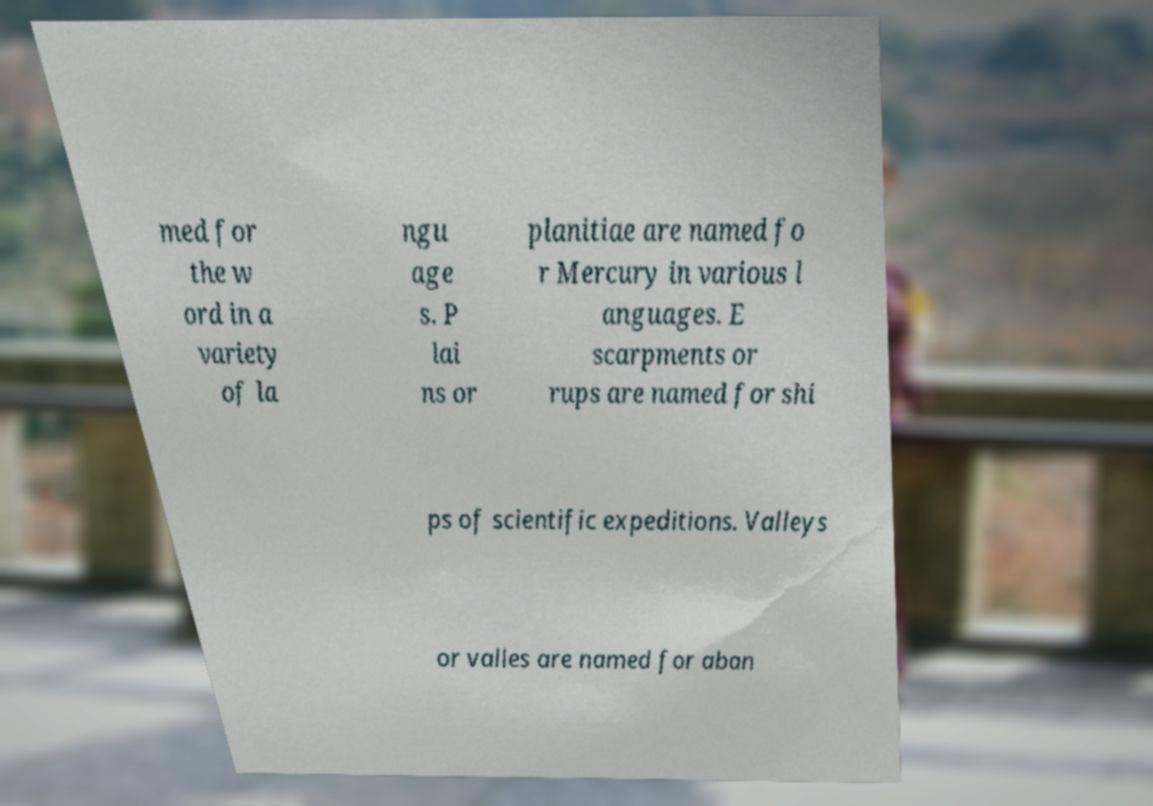There's text embedded in this image that I need extracted. Can you transcribe it verbatim? med for the w ord in a variety of la ngu age s. P lai ns or planitiae are named fo r Mercury in various l anguages. E scarpments or rups are named for shi ps of scientific expeditions. Valleys or valles are named for aban 